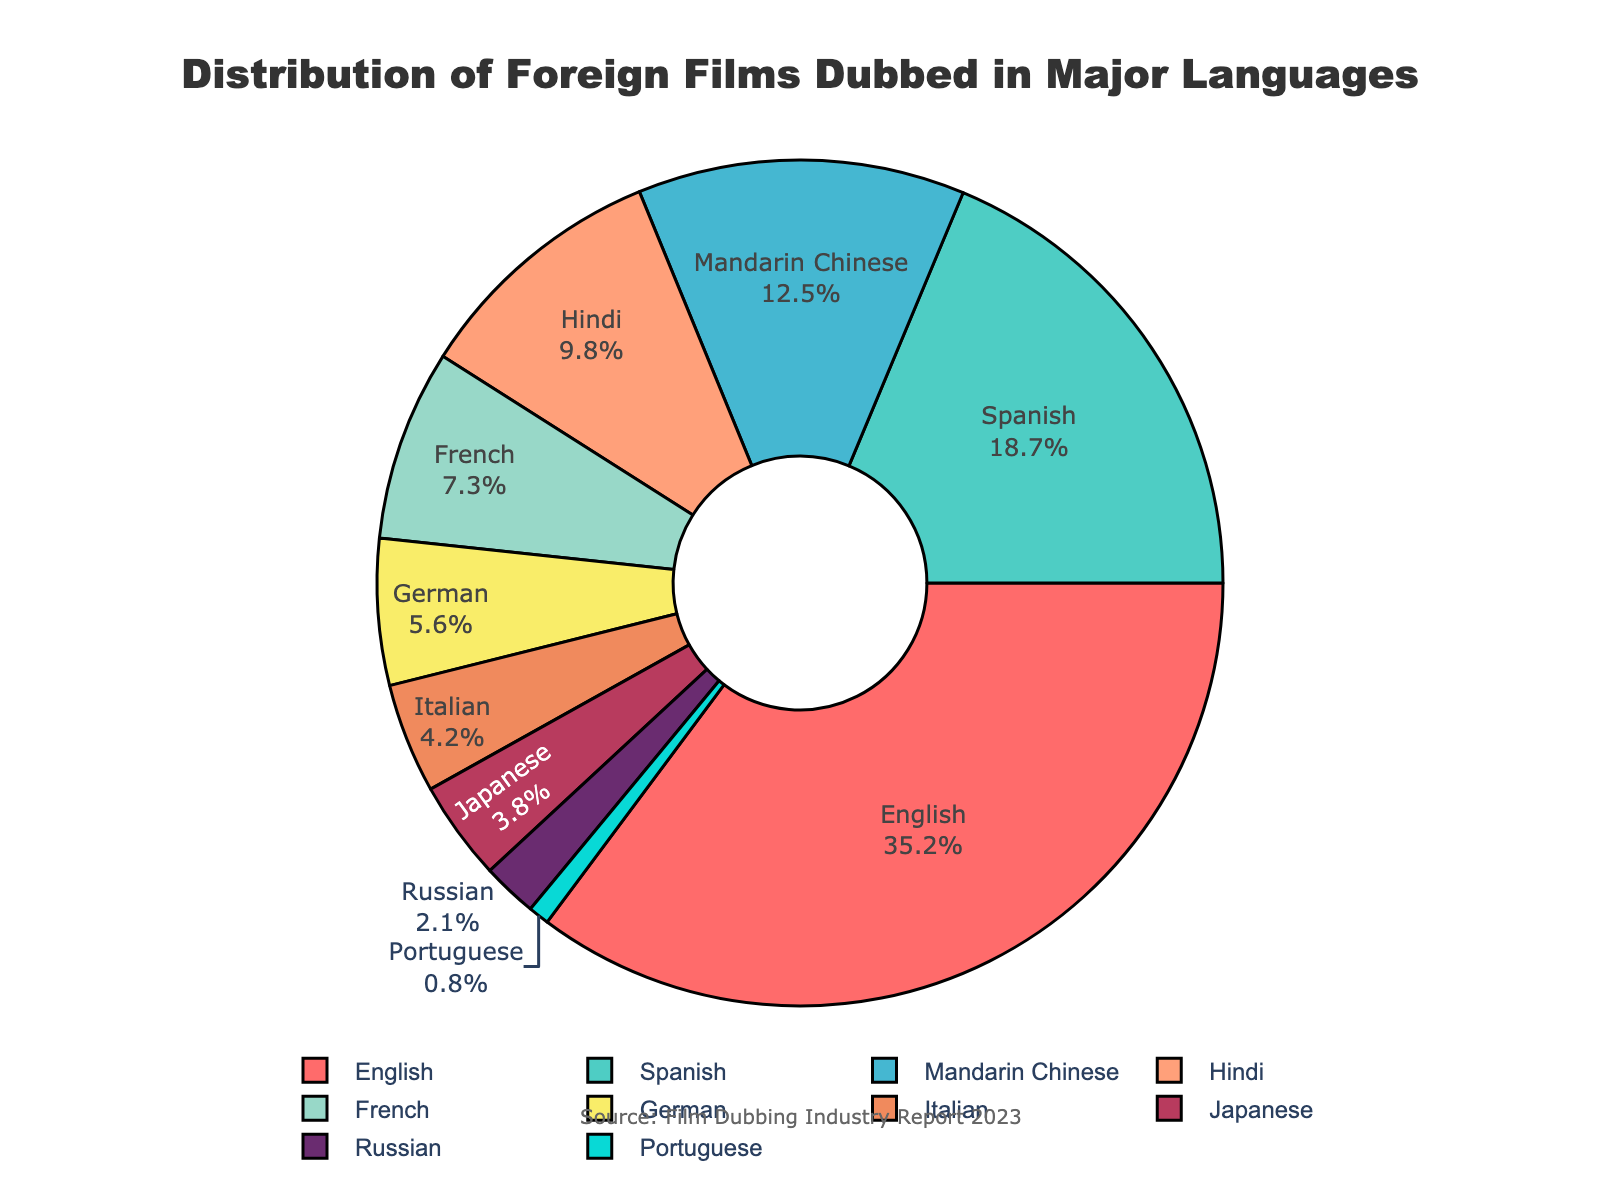What's the most common language for dubbing foreign films? The pie chart shows each language's percentage. By observing the segments, English has the largest portion at 35.2%.
Answer: English Which two languages have a combined percentage closest to 30%? By looking at the percentages, Mandarin Chinese (12.5%) and Hindi (9.8%) sum up to 22.3%, which is close but not enough. Spanish (18.7%) and Portuguese (0.8%) sum up to 19.5%, still not close. German (5.6%) and French (7.3%) add up to 12.9%. Mandarin Chinese (12.5%) and French (7.3%) sum up to 19.8%. Spanish (18.7%) and German (5.6%) is 24.3%. Spanish (18.7%) and Hindi (9.8%) sum to 28.5%, which is the closest.
Answer: Spanish and Hindi How much more popular is dubbing in English compared to Italian? The English segment is labeled at 35.2% and the Italian segment at 4.2%. Calculate the difference: 35.2% - 4.2% = 31%.
Answer: 31% Which languages collectively occupy more than half of the chart? By visually adding the largest sections, English (35.2%) followed by Spanish (18.7%) already totals to 53.9%. Thus, English and Spanish collectively take up more than half.
Answer: English and Spanish Among Mandarin Chinese and Japanese, which language dubs more films and by how much? The pie chart shows Mandarin Chinese at 12.5% and Japanese at 3.8%. The difference is 12.5% - 3.8% = 8.7%.
Answer: Mandarin Chinese by 8.7% Rank the top three languages for dubbing in descending order of their percentage. Observing the pie chart, English leads at 35.2%, followed by Spanish at 18.7%, and Mandarin Chinese at 12.5%.
Answer: English, Spanish, Mandarin Chinese What percent of films are dubbed in either German or Italian? The pie chart shows German at 5.6% and Italian at 4.2%. Add the percentages: 5.6% + 4.2% = 9.8%.
Answer: 9.8% If you combine Hindi, French, and Russian, is their total percentage greater than Spanish? Hindi (9.8%) + French (7.3%) + Russian (2.1%) sums to 19.2%. Spanish alone is 18.7%, so the combined percentage is greater than Spanish.
Answer: Yes What colors are used for the segments representing the two least common languages? By checking the pie chart, the two least common languages are Portuguese (0.8%) and Russian (2.1%). The colors for these segments are found visually on the chart.
Answer: Light blue for Portuguese and pink for Russian 